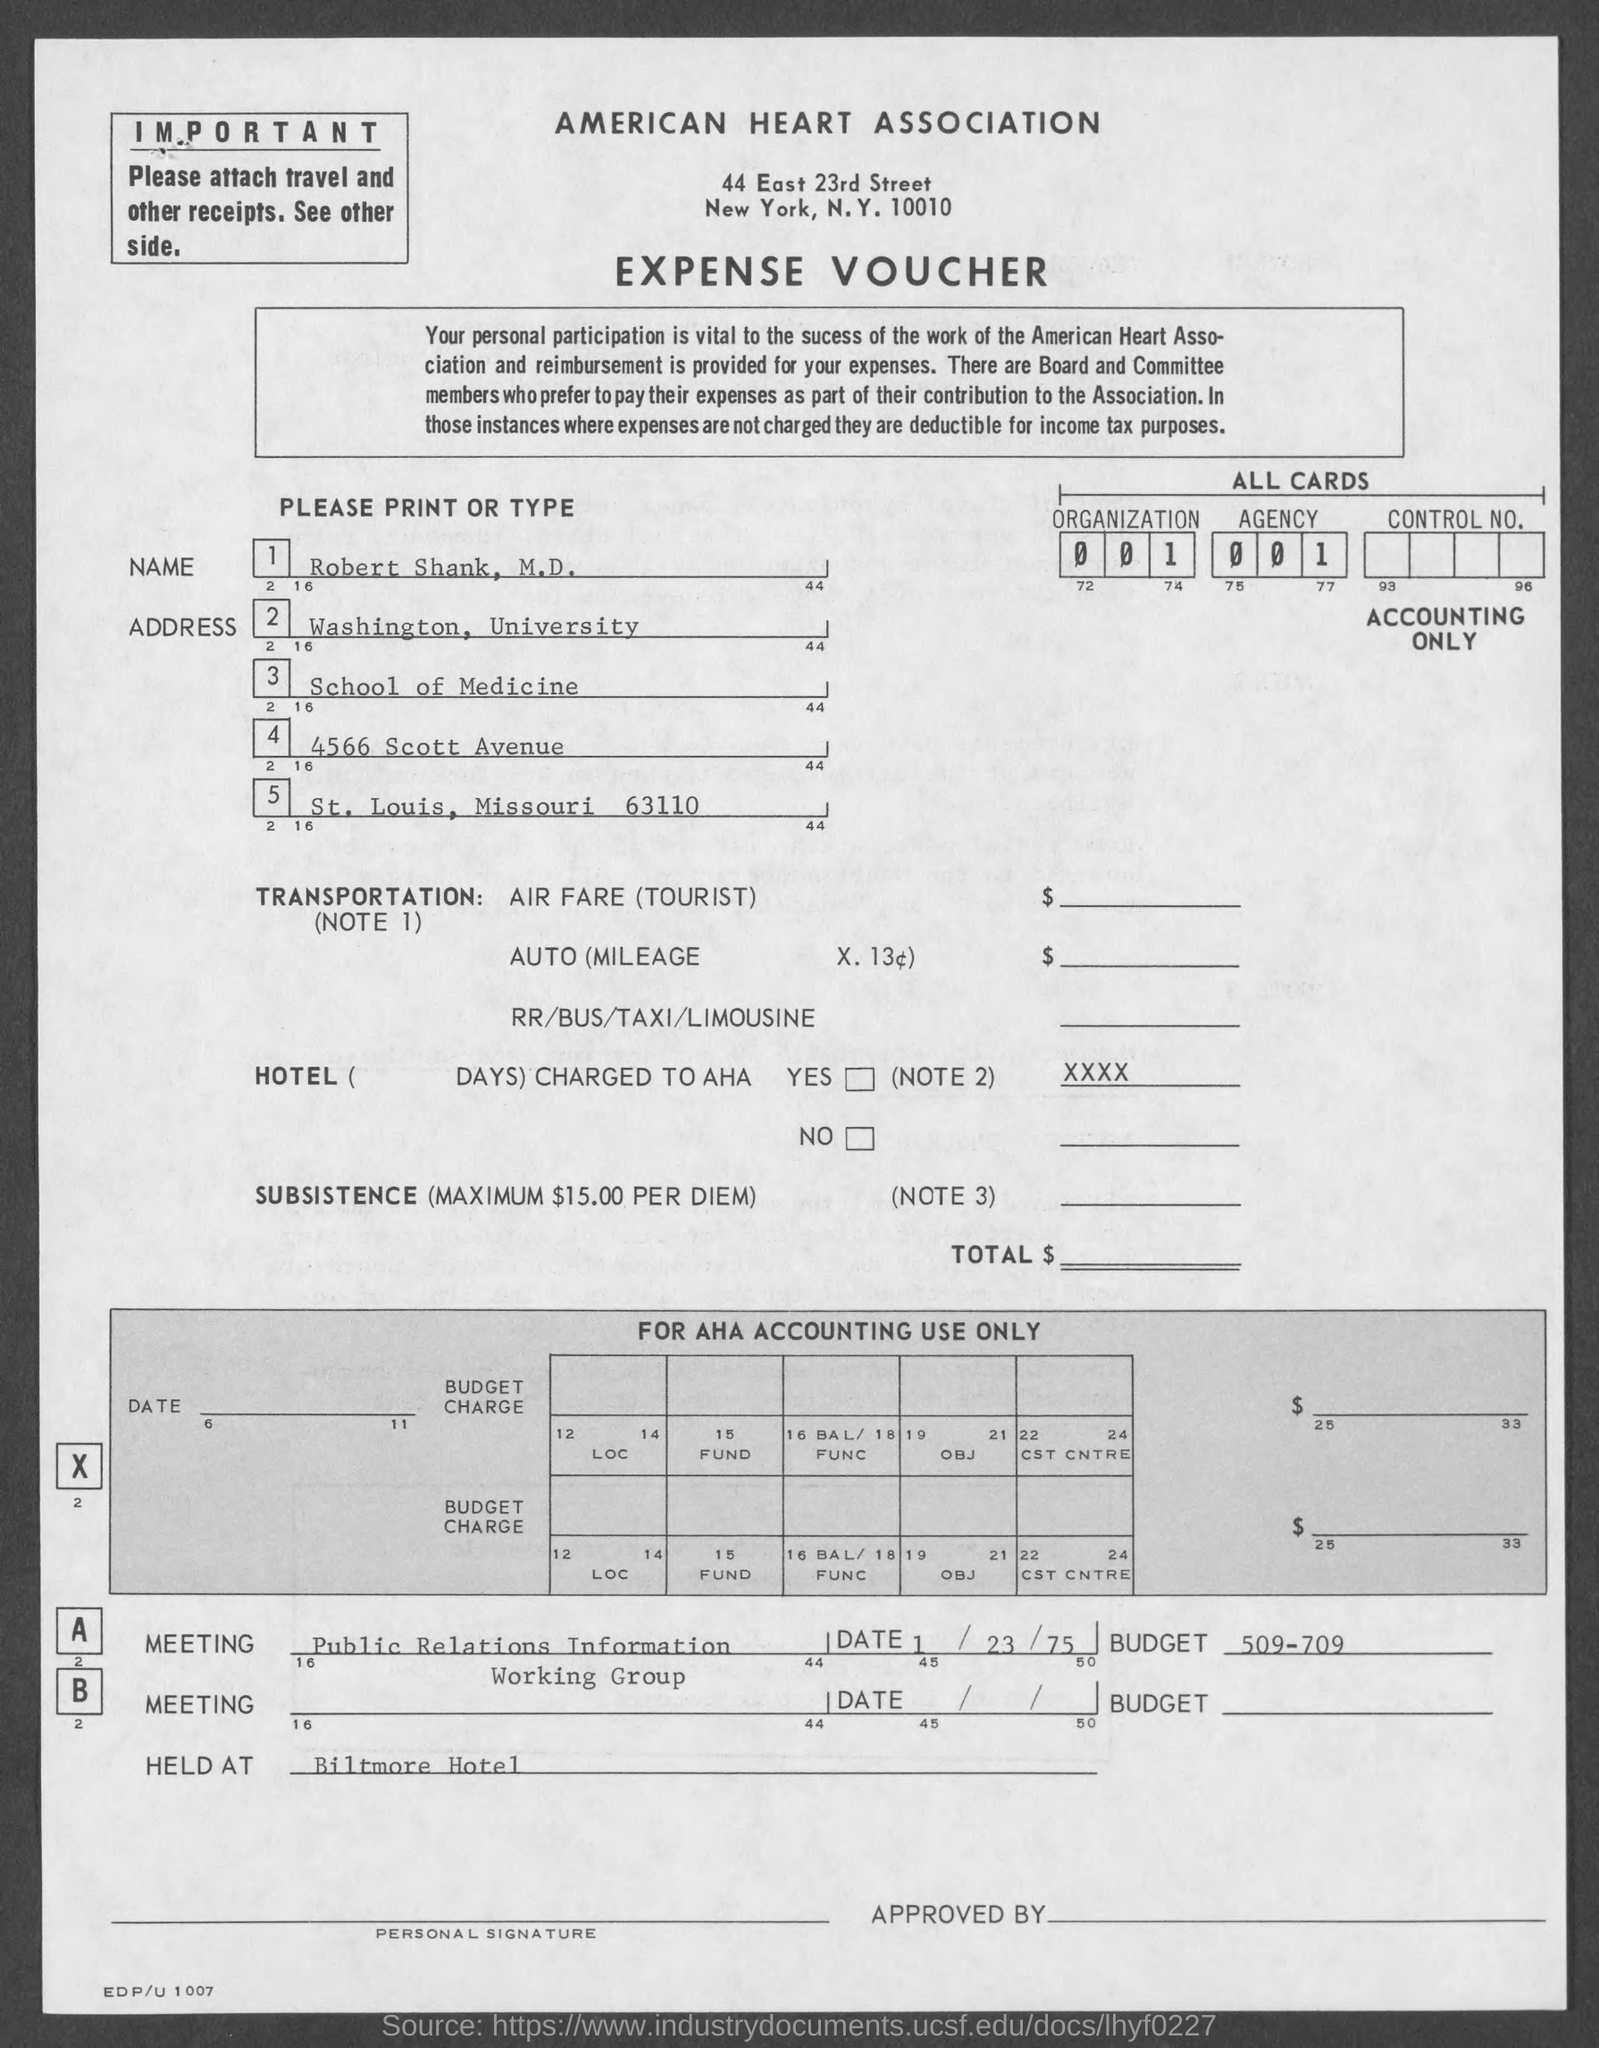What was the budget of meeting A? The budget for Meeting A, titled 'Public Relations Information Working Group', was listed as $509-709. 